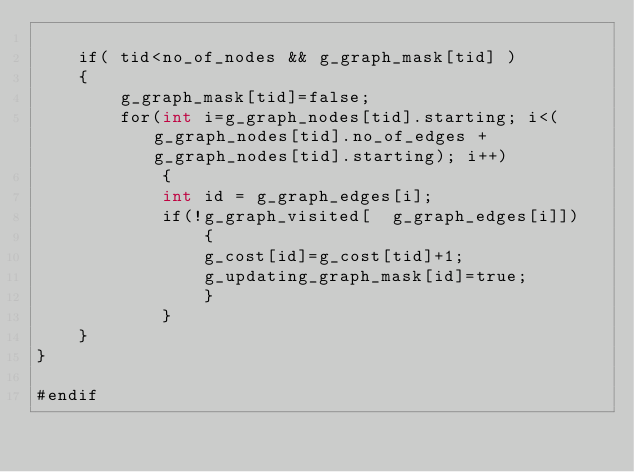<code> <loc_0><loc_0><loc_500><loc_500><_Cuda_>
	if( tid<no_of_nodes && g_graph_mask[tid] )
	{
		g_graph_mask[tid]=false;
		for(int i=g_graph_nodes[tid].starting; i<(g_graph_nodes[tid].no_of_edges + g_graph_nodes[tid].starting); i++)
			{
			int id = g_graph_edges[i];
			if(!g_graph_visited[  g_graph_edges[i]])
				{
				g_cost[id]=g_cost[tid]+1;
				g_updating_graph_mask[id]=true;
				}
			}
	}
}

#endif 
</code> 